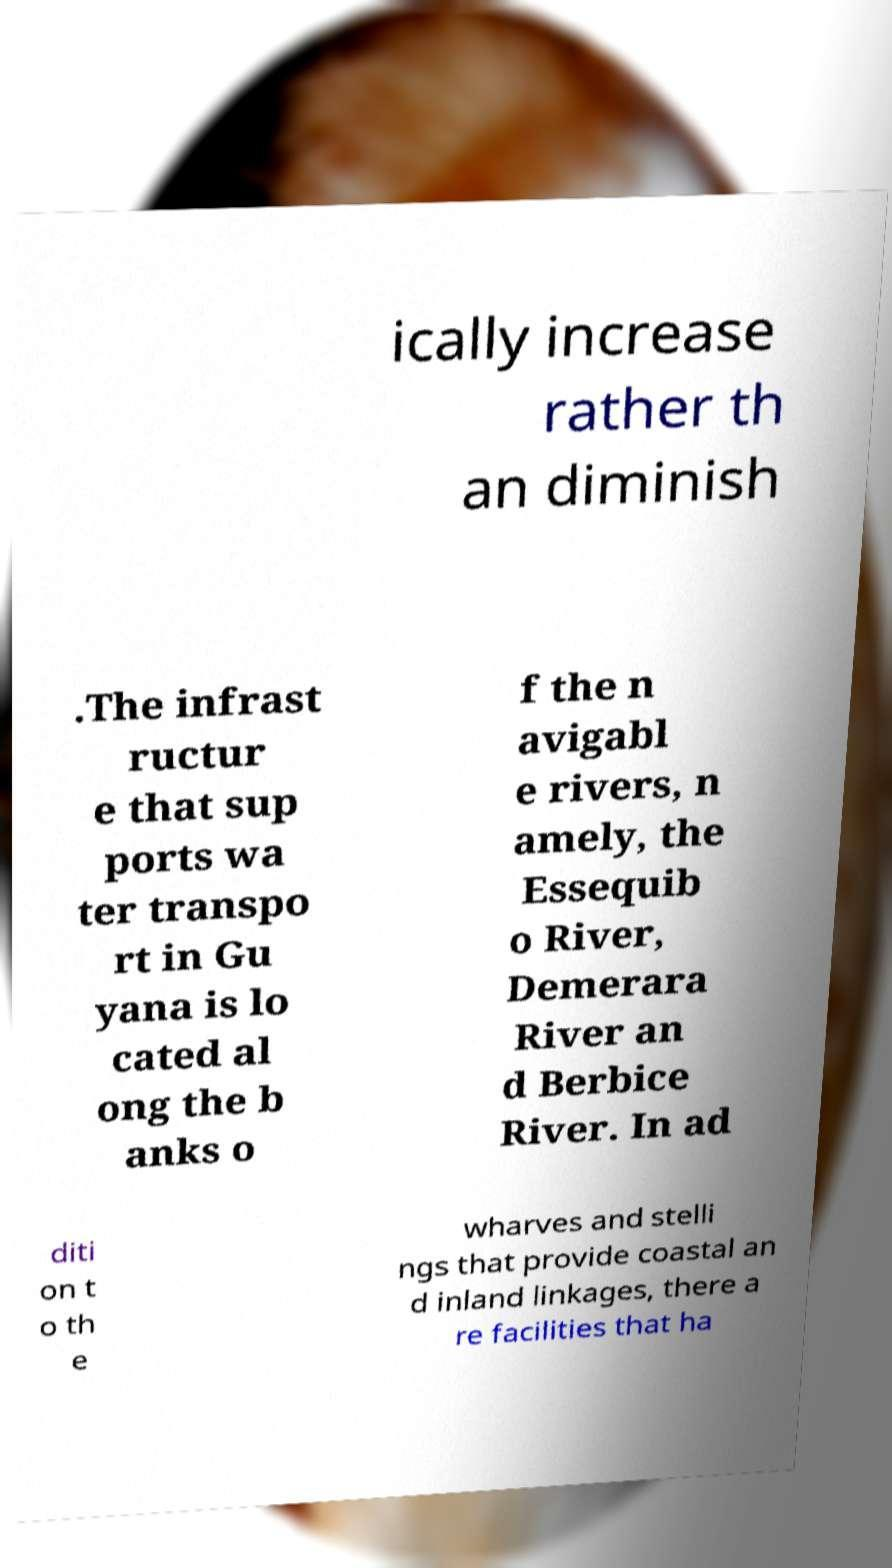For documentation purposes, I need the text within this image transcribed. Could you provide that? ically increase rather th an diminish .The infrast ructur e that sup ports wa ter transpo rt in Gu yana is lo cated al ong the b anks o f the n avigabl e rivers, n amely, the Essequib o River, Demerara River an d Berbice River. In ad diti on t o th e wharves and stelli ngs that provide coastal an d inland linkages, there a re facilities that ha 